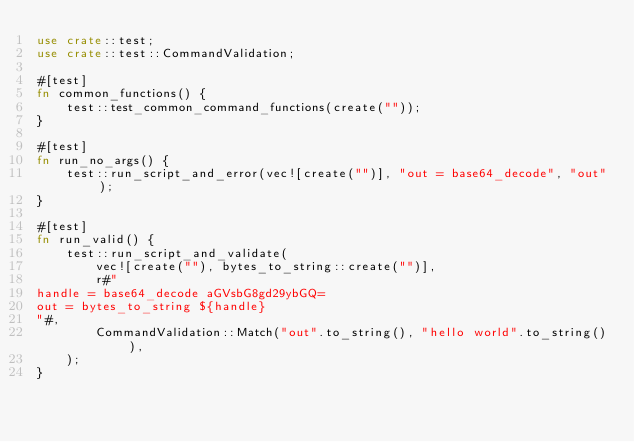Convert code to text. <code><loc_0><loc_0><loc_500><loc_500><_Rust_>use crate::test;
use crate::test::CommandValidation;

#[test]
fn common_functions() {
    test::test_common_command_functions(create(""));
}

#[test]
fn run_no_args() {
    test::run_script_and_error(vec![create("")], "out = base64_decode", "out");
}

#[test]
fn run_valid() {
    test::run_script_and_validate(
        vec![create(""), bytes_to_string::create("")],
        r#"
handle = base64_decode aGVsbG8gd29ybGQ=
out = bytes_to_string ${handle}
"#,
        CommandValidation::Match("out".to_string(), "hello world".to_string()),
    );
}
</code> 